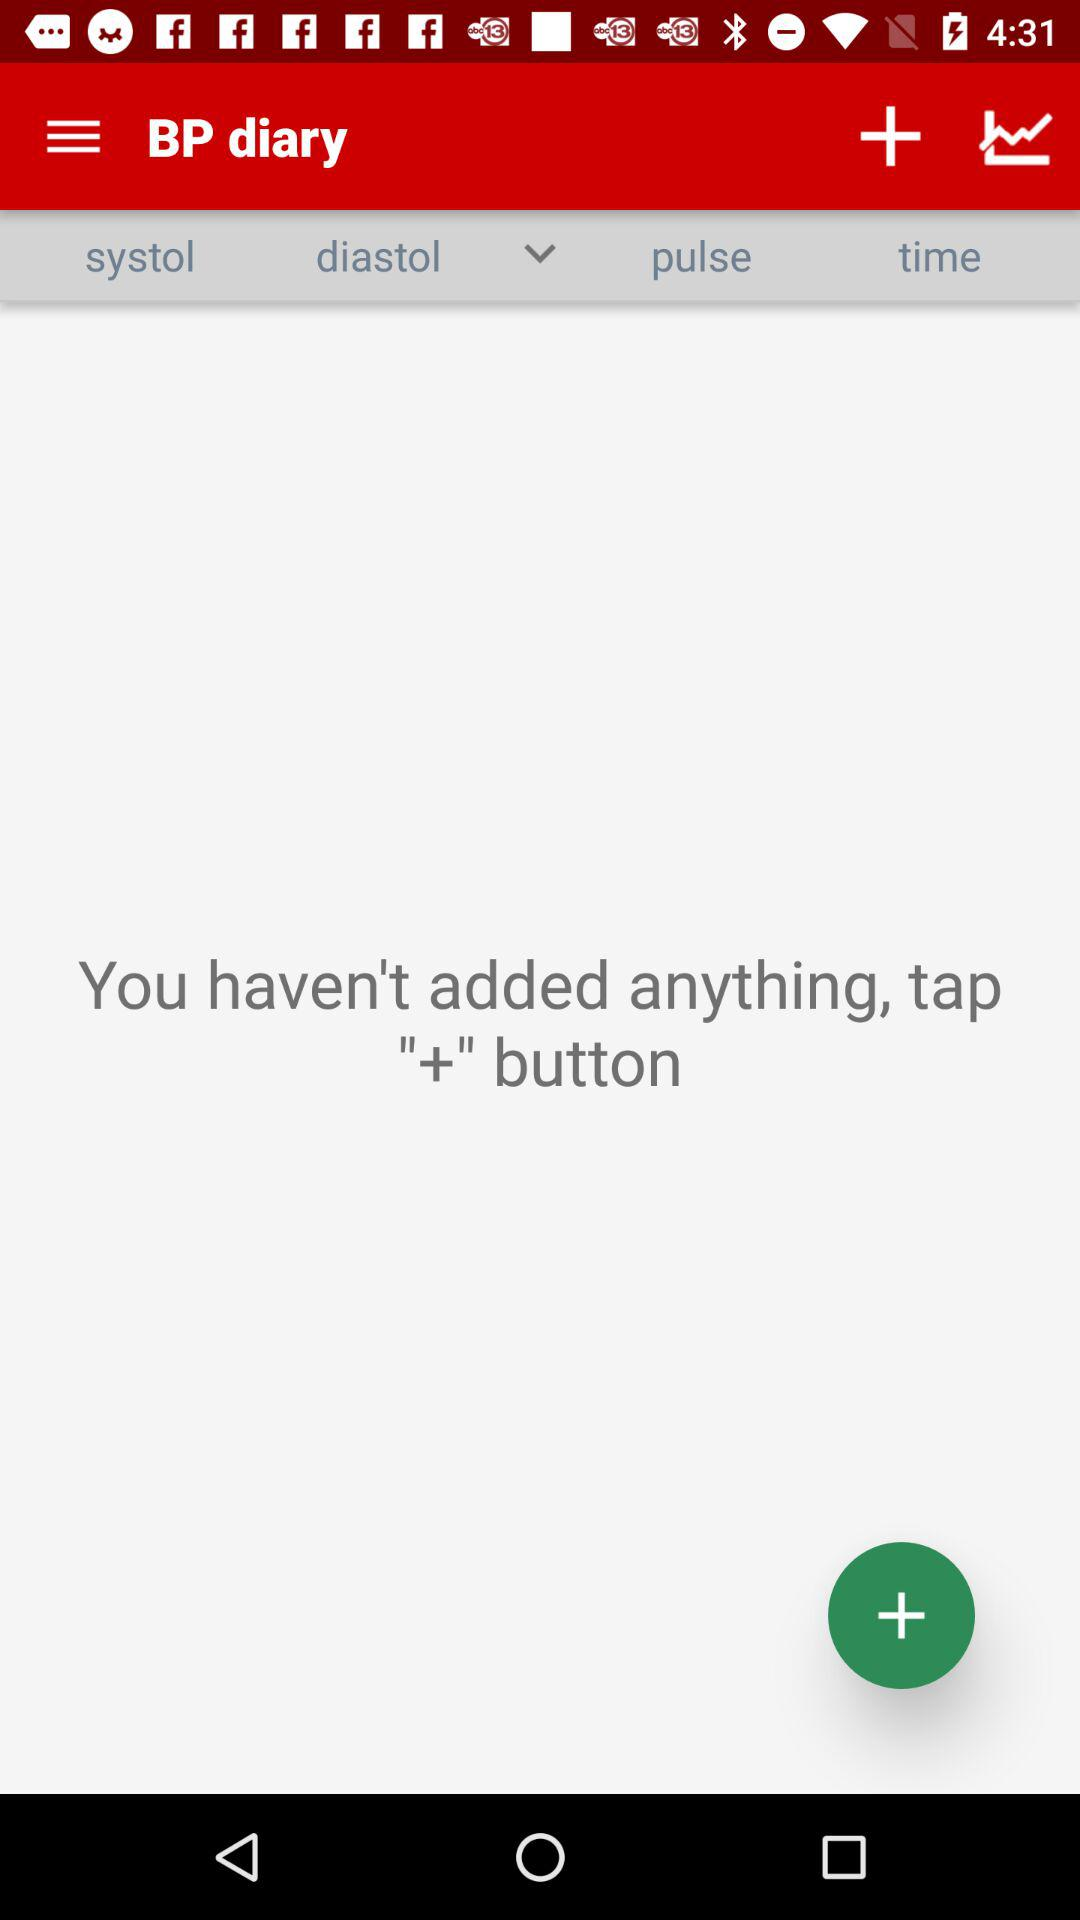What is the application name? The application name is "BP diary". 